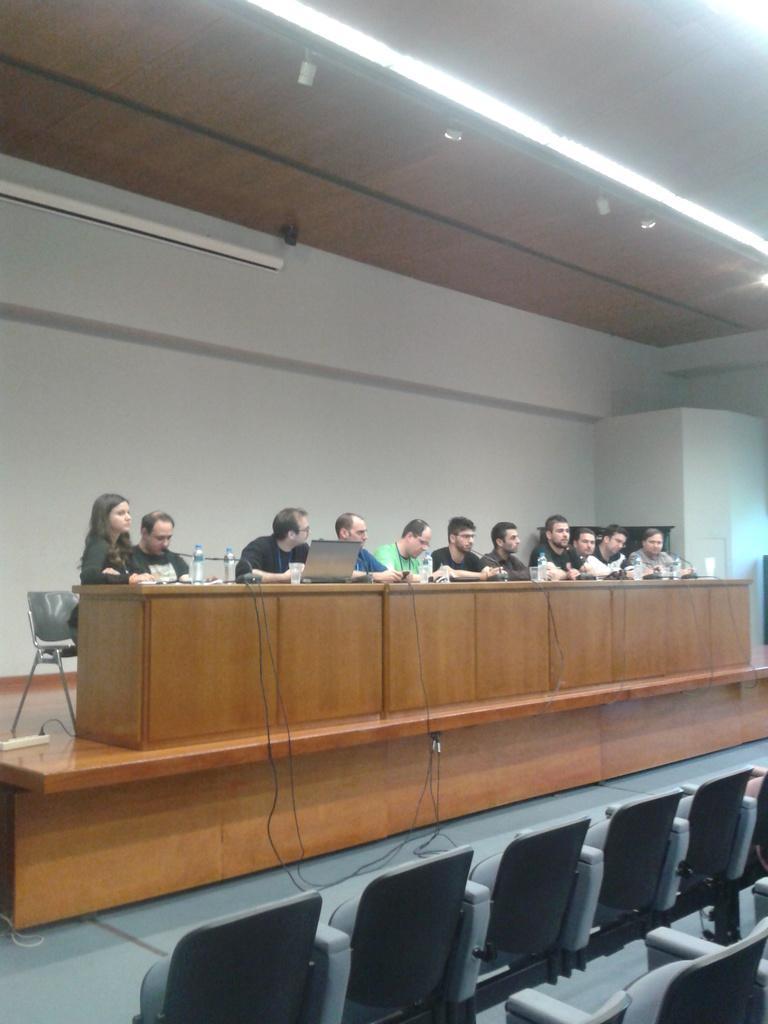Please provide a concise description of this image. In this image I can see some people sitting on the chairs. In front of these people there is a table. And there are some bottles and one laptop on it. In the background there is a wall. On the bottom of this image I can see some empty chairs. 